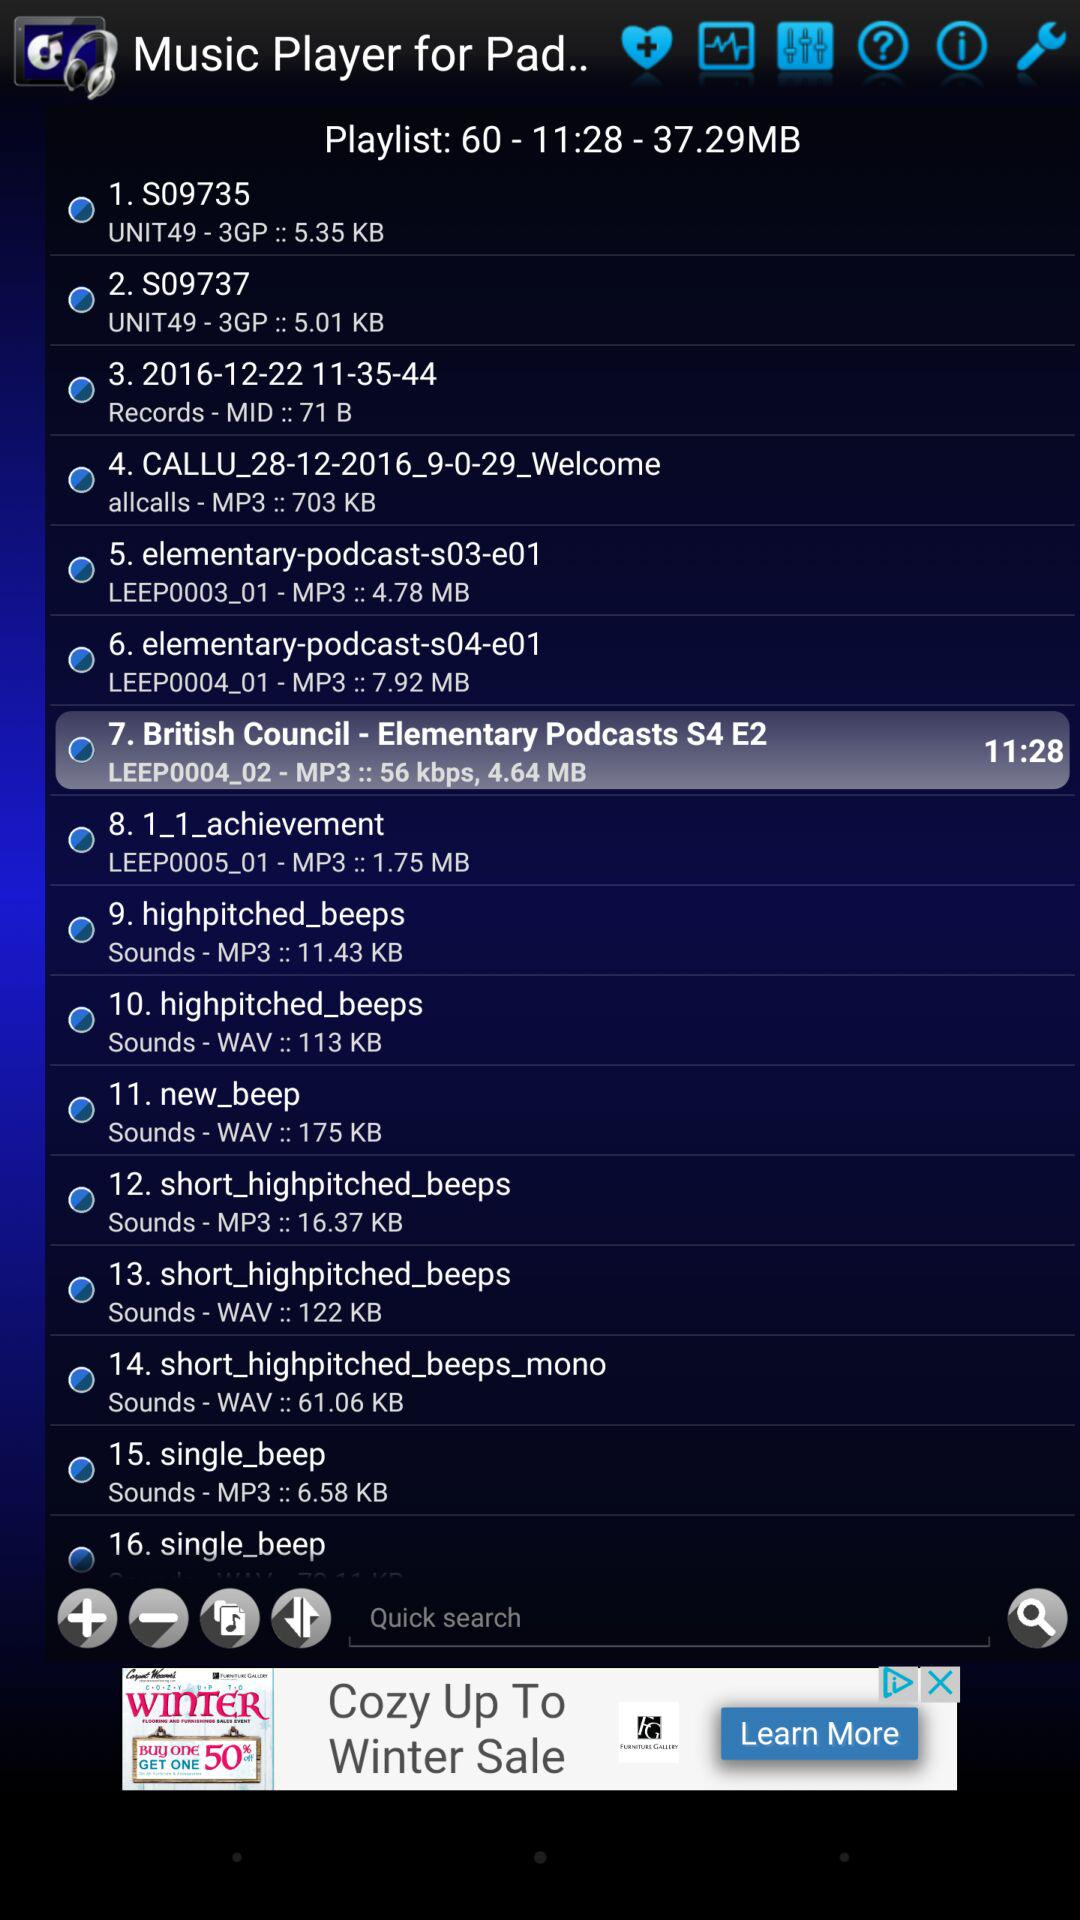What's the duration of the seventh audio? The duration is 11 minutes 28 seconds. 